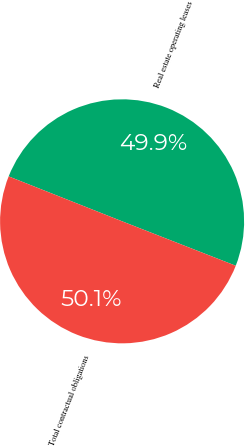Convert chart to OTSL. <chart><loc_0><loc_0><loc_500><loc_500><pie_chart><fcel>Real estate operating leases<fcel>Total contractual obligations<nl><fcel>49.93%<fcel>50.07%<nl></chart> 